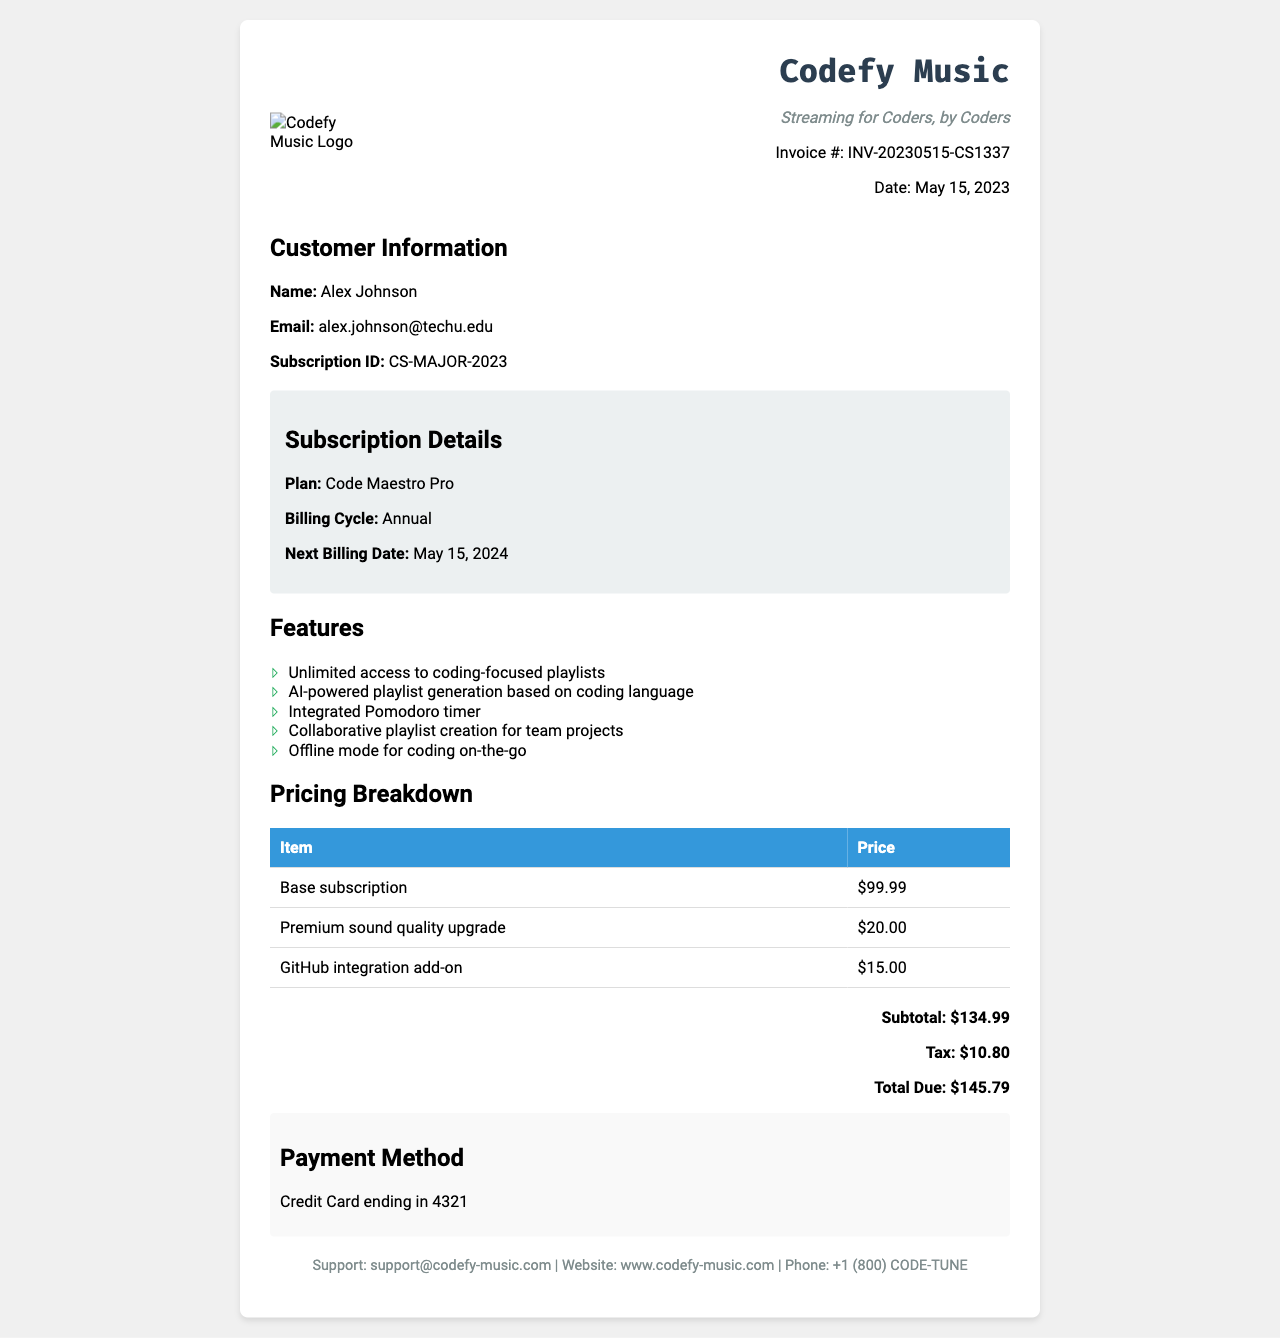What is the invoice number? The invoice number is listed in the document as an identifier for the invoice.
Answer: INV-20230515-CS1337 What is the total due amount? The total due amount is calculated from the subtotal and tax mentioned in the document.
Answer: $145.79 What is the customer's email? The customer's email is displayed under the customer information section.
Answer: alex.johnson@techu.edu What is the billing cycle? The billing cycle indicates how often the subscription is billed, as noted in the subscription details.
Answer: Annual What features are included in the subscription? The features listed provide details on what the subscription offers, which includes a range of services.
Answer: Unlimited access to coding-focused playlists, AI-powered playlist generation based on coding language, Integrated Pomodoro timer, Collaborative playlist creation for team projects, Offline mode for coding on-the-go What is the name of the subscription plan? The subscription plan is specified in the subscription details section of the document.
Answer: Code Maestro Pro How much is the premium sound quality upgrade? The price for the premium sound quality upgrade can be found in the pricing breakdown table.
Answer: $20.00 When is the next billing date? The next billing date is mentioned in the subscription details, indicating when the next payment is due.
Answer: May 15, 2024 What payment method was used? The payment method indicates how the customer plans to pay for the subscription, as noted in the payment method section.
Answer: Credit Card ending in 4321 What company is sending the invoice? The company name is prominently displayed at the top of the invoice in the header section.
Answer: Codefy Music 